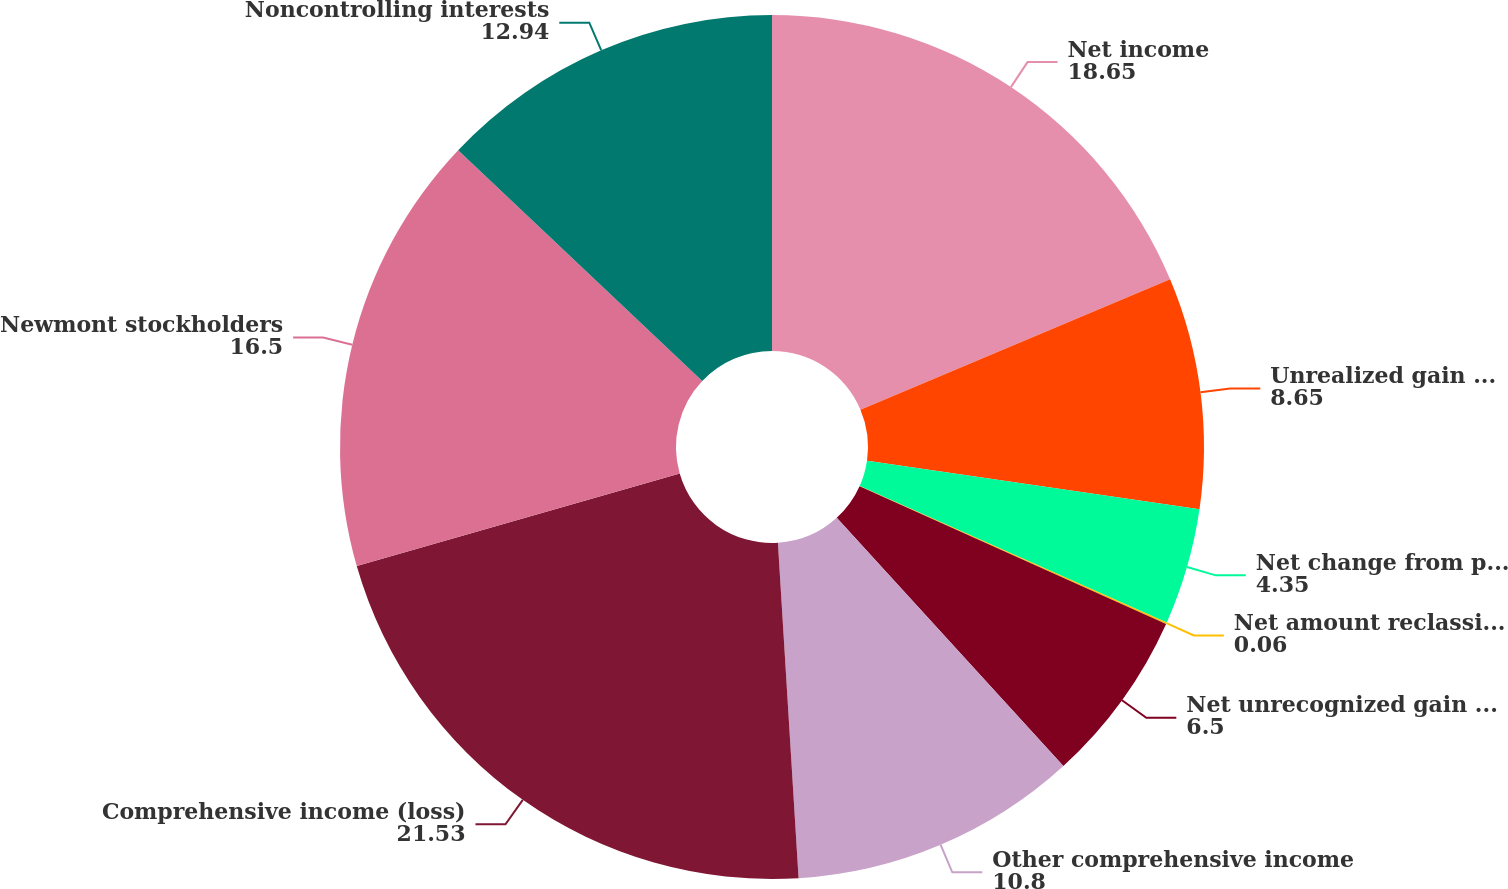<chart> <loc_0><loc_0><loc_500><loc_500><pie_chart><fcel>Net income<fcel>Unrealized gain (loss) on<fcel>Net change from periodic<fcel>Net amount reclassified to<fcel>Net unrecognized gain (loss)<fcel>Other comprehensive income<fcel>Comprehensive income (loss)<fcel>Newmont stockholders<fcel>Noncontrolling interests<nl><fcel>18.65%<fcel>8.65%<fcel>4.35%<fcel>0.06%<fcel>6.5%<fcel>10.8%<fcel>21.53%<fcel>16.5%<fcel>12.94%<nl></chart> 